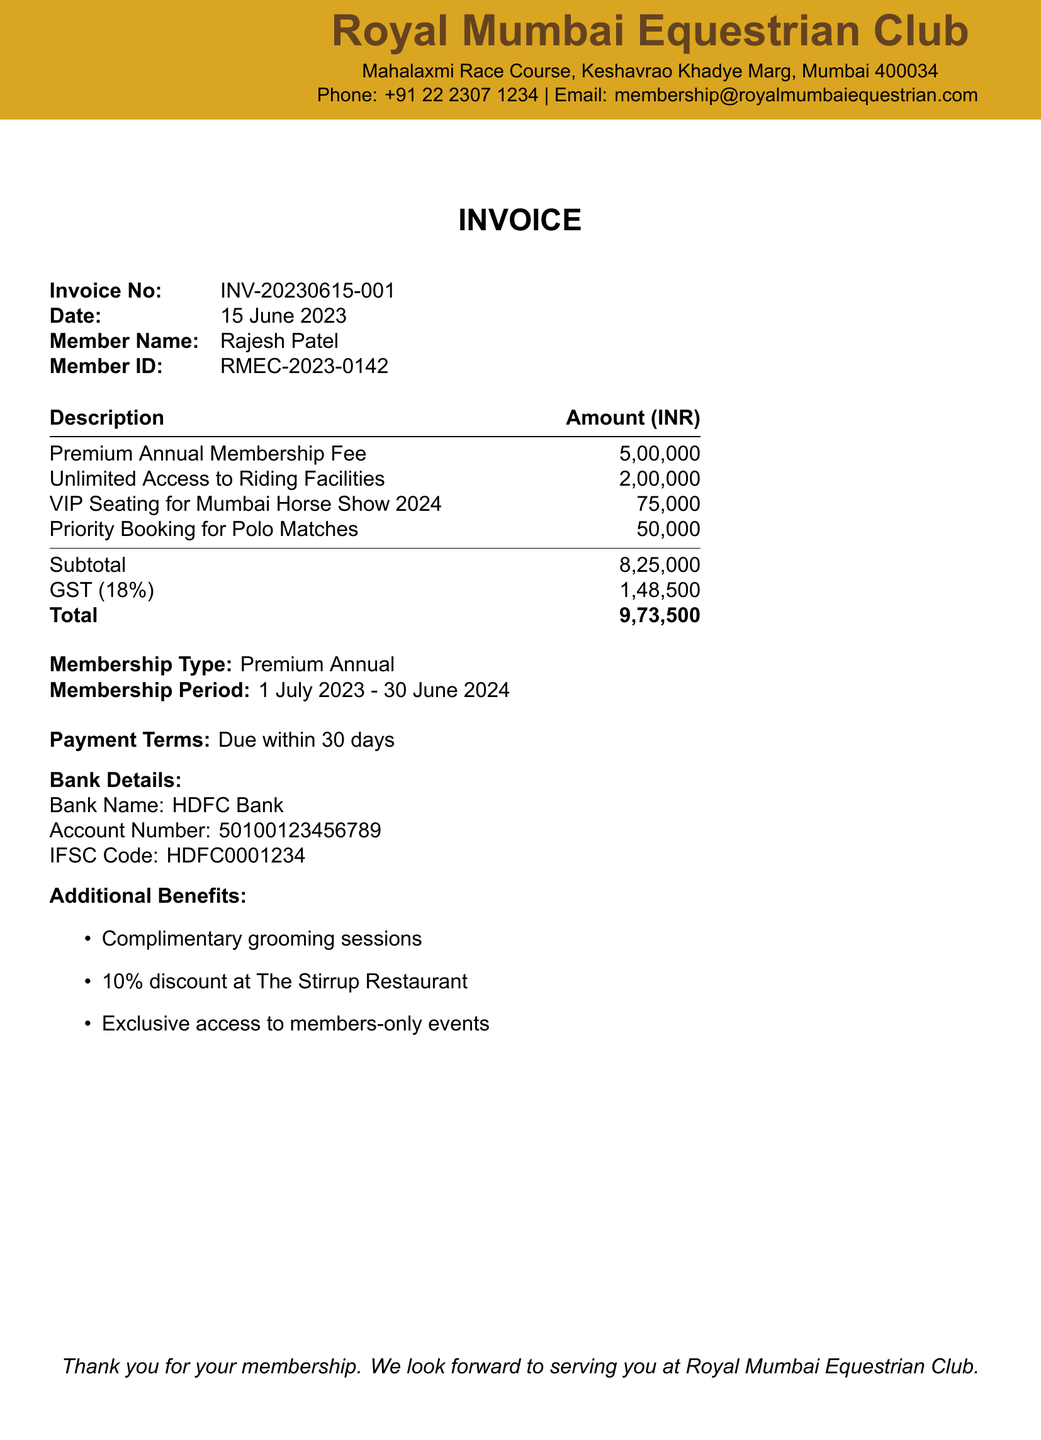What is the invoice number? The invoice number is a unique identifier for the transaction detailed in the document.
Answer: INV-20230615-001 What is the total amount due? The total amount is displayed at the bottom of the invoice, including all fees and taxes.
Answer: 9,73,500 Who is the member? The member's name appears near the top of the invoice and identifies the person associated with the membership.
Answer: Rajesh Patel What is the membership duration? The membership duration specifies the start and end date of the membership period noted in the document.
Answer: 1 July 2023 - 30 June 2024 What is the GST percentage? The GST percentage is indicated in the subtotal calculation section and affects the total amount due.
Answer: 18% What is the address of the club? The address provides the location of the Royal Mumbai Equestrian Club as mentioned at the top.
Answer: Mahalaxmi Race Course, Keshavrao Khadye Marg, Mumbai 400034 How much is the Premium Annual Membership Fee? The Premium Annual Membership Fee is listed as a separate item in the amount breakdown.
Answer: 5,00,000 What additional benefits are included in the membership? The additional benefits section lists perks that come with the membership, enhancing the value of the package.
Answer: Complimentary grooming sessions, 10% discount at The Stirrup Restaurant, Exclusive access to members-only events What is the payment term? The payment term states the conditions under which the payment is expected to be made.
Answer: Due within 30 days 